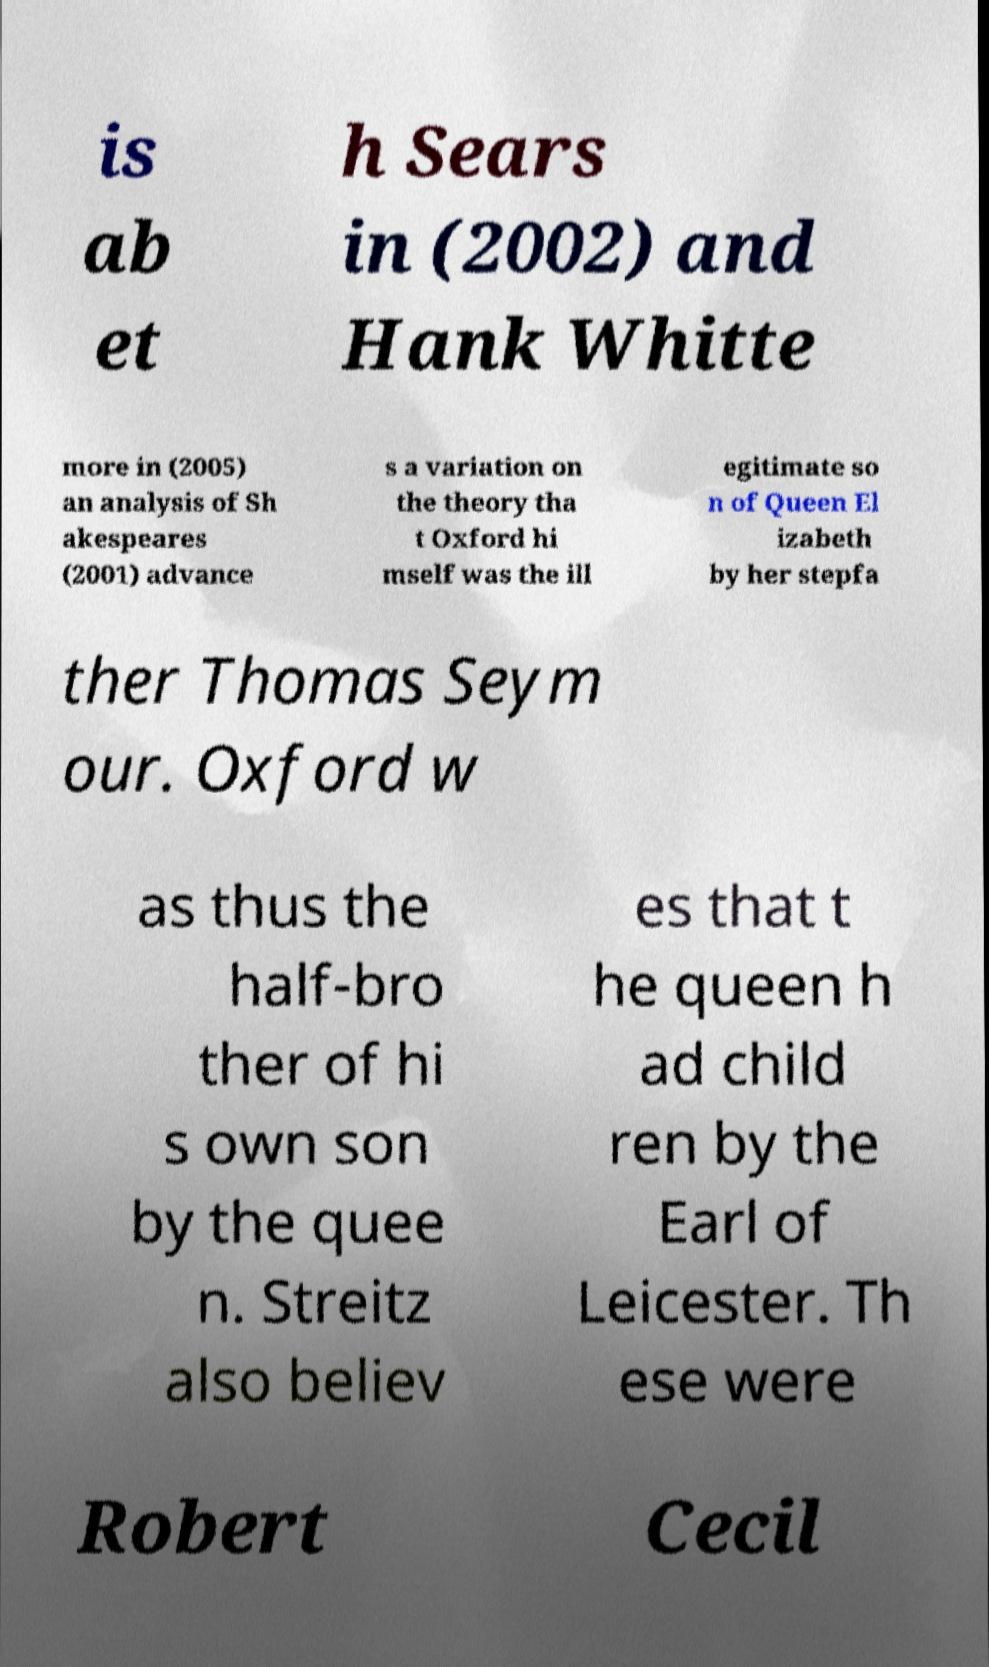Could you extract and type out the text from this image? is ab et h Sears in (2002) and Hank Whitte more in (2005) an analysis of Sh akespeares (2001) advance s a variation on the theory tha t Oxford hi mself was the ill egitimate so n of Queen El izabeth by her stepfa ther Thomas Seym our. Oxford w as thus the half-bro ther of hi s own son by the quee n. Streitz also believ es that t he queen h ad child ren by the Earl of Leicester. Th ese were Robert Cecil 